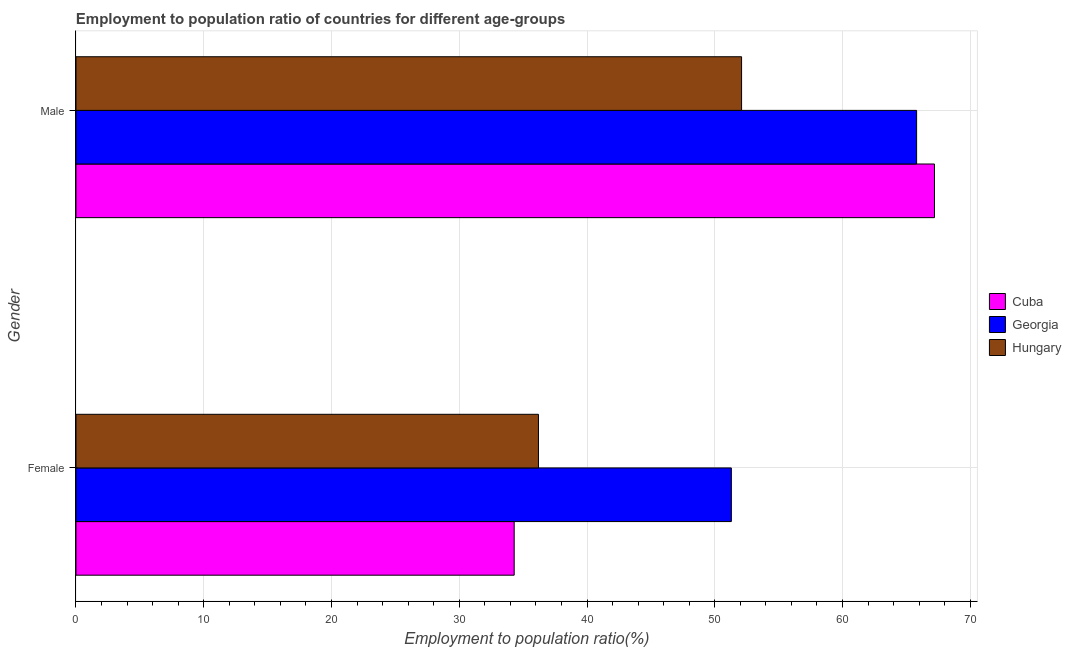How many groups of bars are there?
Your response must be concise. 2. How many bars are there on the 1st tick from the top?
Provide a short and direct response. 3. What is the label of the 2nd group of bars from the top?
Provide a short and direct response. Female. What is the employment to population ratio(male) in Hungary?
Your answer should be very brief. 52.1. Across all countries, what is the maximum employment to population ratio(female)?
Give a very brief answer. 51.3. Across all countries, what is the minimum employment to population ratio(male)?
Provide a short and direct response. 52.1. In which country was the employment to population ratio(male) maximum?
Make the answer very short. Cuba. In which country was the employment to population ratio(female) minimum?
Your answer should be very brief. Cuba. What is the total employment to population ratio(female) in the graph?
Your answer should be compact. 121.8. What is the difference between the employment to population ratio(male) in Georgia and that in Cuba?
Provide a short and direct response. -1.4. What is the difference between the employment to population ratio(female) in Georgia and the employment to population ratio(male) in Hungary?
Make the answer very short. -0.8. What is the average employment to population ratio(female) per country?
Give a very brief answer. 40.6. What is the difference between the employment to population ratio(female) and employment to population ratio(male) in Georgia?
Offer a terse response. -14.5. In how many countries, is the employment to population ratio(female) greater than 36 %?
Ensure brevity in your answer.  2. What is the ratio of the employment to population ratio(male) in Hungary to that in Cuba?
Make the answer very short. 0.78. Is the employment to population ratio(male) in Hungary less than that in Cuba?
Provide a succinct answer. Yes. What does the 2nd bar from the top in Female represents?
Make the answer very short. Georgia. What does the 1st bar from the bottom in Female represents?
Ensure brevity in your answer.  Cuba. Are all the bars in the graph horizontal?
Provide a short and direct response. Yes. What is the difference between two consecutive major ticks on the X-axis?
Keep it short and to the point. 10. Does the graph contain any zero values?
Make the answer very short. No. Where does the legend appear in the graph?
Keep it short and to the point. Center right. How many legend labels are there?
Your response must be concise. 3. What is the title of the graph?
Your answer should be compact. Employment to population ratio of countries for different age-groups. What is the label or title of the Y-axis?
Offer a very short reply. Gender. What is the Employment to population ratio(%) of Cuba in Female?
Ensure brevity in your answer.  34.3. What is the Employment to population ratio(%) in Georgia in Female?
Keep it short and to the point. 51.3. What is the Employment to population ratio(%) of Hungary in Female?
Your answer should be very brief. 36.2. What is the Employment to population ratio(%) of Cuba in Male?
Ensure brevity in your answer.  67.2. What is the Employment to population ratio(%) in Georgia in Male?
Offer a very short reply. 65.8. What is the Employment to population ratio(%) of Hungary in Male?
Offer a very short reply. 52.1. Across all Gender, what is the maximum Employment to population ratio(%) in Cuba?
Your answer should be very brief. 67.2. Across all Gender, what is the maximum Employment to population ratio(%) in Georgia?
Offer a very short reply. 65.8. Across all Gender, what is the maximum Employment to population ratio(%) in Hungary?
Offer a terse response. 52.1. Across all Gender, what is the minimum Employment to population ratio(%) in Cuba?
Provide a succinct answer. 34.3. Across all Gender, what is the minimum Employment to population ratio(%) of Georgia?
Keep it short and to the point. 51.3. Across all Gender, what is the minimum Employment to population ratio(%) of Hungary?
Keep it short and to the point. 36.2. What is the total Employment to population ratio(%) in Cuba in the graph?
Keep it short and to the point. 101.5. What is the total Employment to population ratio(%) of Georgia in the graph?
Make the answer very short. 117.1. What is the total Employment to population ratio(%) in Hungary in the graph?
Make the answer very short. 88.3. What is the difference between the Employment to population ratio(%) of Cuba in Female and that in Male?
Provide a succinct answer. -32.9. What is the difference between the Employment to population ratio(%) in Hungary in Female and that in Male?
Your answer should be compact. -15.9. What is the difference between the Employment to population ratio(%) in Cuba in Female and the Employment to population ratio(%) in Georgia in Male?
Make the answer very short. -31.5. What is the difference between the Employment to population ratio(%) in Cuba in Female and the Employment to population ratio(%) in Hungary in Male?
Offer a very short reply. -17.8. What is the difference between the Employment to population ratio(%) of Georgia in Female and the Employment to population ratio(%) of Hungary in Male?
Provide a succinct answer. -0.8. What is the average Employment to population ratio(%) in Cuba per Gender?
Make the answer very short. 50.75. What is the average Employment to population ratio(%) in Georgia per Gender?
Your answer should be compact. 58.55. What is the average Employment to population ratio(%) of Hungary per Gender?
Give a very brief answer. 44.15. What is the difference between the Employment to population ratio(%) in Cuba and Employment to population ratio(%) in Georgia in Female?
Provide a short and direct response. -17. What is the difference between the Employment to population ratio(%) of Cuba and Employment to population ratio(%) of Hungary in Female?
Offer a terse response. -1.9. What is the difference between the Employment to population ratio(%) in Cuba and Employment to population ratio(%) in Georgia in Male?
Provide a succinct answer. 1.4. What is the difference between the Employment to population ratio(%) of Cuba and Employment to population ratio(%) of Hungary in Male?
Your response must be concise. 15.1. What is the difference between the Employment to population ratio(%) in Georgia and Employment to population ratio(%) in Hungary in Male?
Make the answer very short. 13.7. What is the ratio of the Employment to population ratio(%) in Cuba in Female to that in Male?
Ensure brevity in your answer.  0.51. What is the ratio of the Employment to population ratio(%) of Georgia in Female to that in Male?
Keep it short and to the point. 0.78. What is the ratio of the Employment to population ratio(%) in Hungary in Female to that in Male?
Your response must be concise. 0.69. What is the difference between the highest and the second highest Employment to population ratio(%) in Cuba?
Offer a very short reply. 32.9. What is the difference between the highest and the second highest Employment to population ratio(%) of Georgia?
Ensure brevity in your answer.  14.5. What is the difference between the highest and the lowest Employment to population ratio(%) in Cuba?
Offer a very short reply. 32.9. 